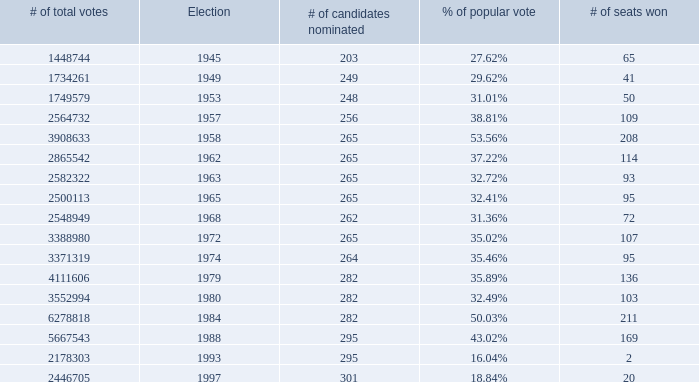What was the lowest # of total votes? 1448744.0. Write the full table. {'header': ['# of total votes', 'Election', '# of candidates nominated', '% of popular vote', '# of seats won'], 'rows': [['1448744', '1945', '203', '27.62%', '65'], ['1734261', '1949', '249', '29.62%', '41'], ['1749579', '1953', '248', '31.01%', '50'], ['2564732', '1957', '256', '38.81%', '109'], ['3908633', '1958', '265', '53.56%', '208'], ['2865542', '1962', '265', '37.22%', '114'], ['2582322', '1963', '265', '32.72%', '93'], ['2500113', '1965', '265', '32.41%', '95'], ['2548949', '1968', '262', '31.36%', '72'], ['3388980', '1972', '265', '35.02%', '107'], ['3371319', '1974', '264', '35.46%', '95'], ['4111606', '1979', '282', '35.89%', '136'], ['3552994', '1980', '282', '32.49%', '103'], ['6278818', '1984', '282', '50.03%', '211'], ['5667543', '1988', '295', '43.02%', '169'], ['2178303', '1993', '295', '16.04%', '2'], ['2446705', '1997', '301', '18.84%', '20']]} 